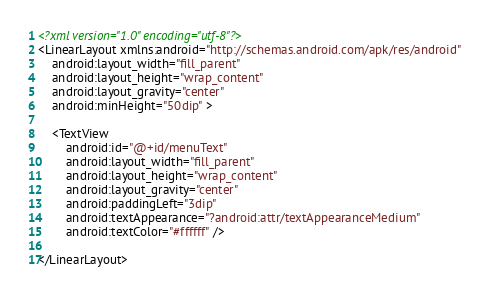Convert code to text. <code><loc_0><loc_0><loc_500><loc_500><_XML_><?xml version="1.0" encoding="utf-8"?>
<LinearLayout xmlns:android="http://schemas.android.com/apk/res/android"
    android:layout_width="fill_parent"
    android:layout_height="wrap_content"
    android:layout_gravity="center"
    android:minHeight="50dip" >

    <TextView
        android:id="@+id/menuText"
        android:layout_width="fill_parent"
        android:layout_height="wrap_content"
        android:layout_gravity="center"
        android:paddingLeft="3dip"
        android:textAppearance="?android:attr/textAppearanceMedium"
        android:textColor="#ffffff" />

</LinearLayout></code> 